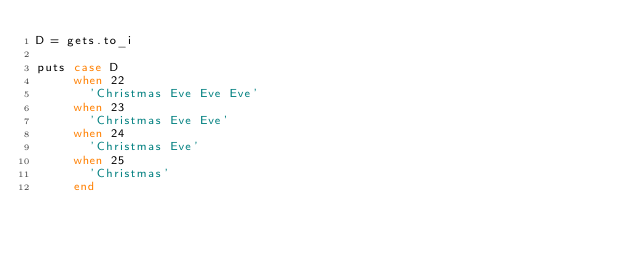<code> <loc_0><loc_0><loc_500><loc_500><_Ruby_>D = gets.to_i

puts case D
     when 22
       'Christmas Eve Eve Eve'
     when 23
       'Christmas Eve Eve'
     when 24
       'Christmas Eve'
     when 25
       'Christmas'
     end
</code> 